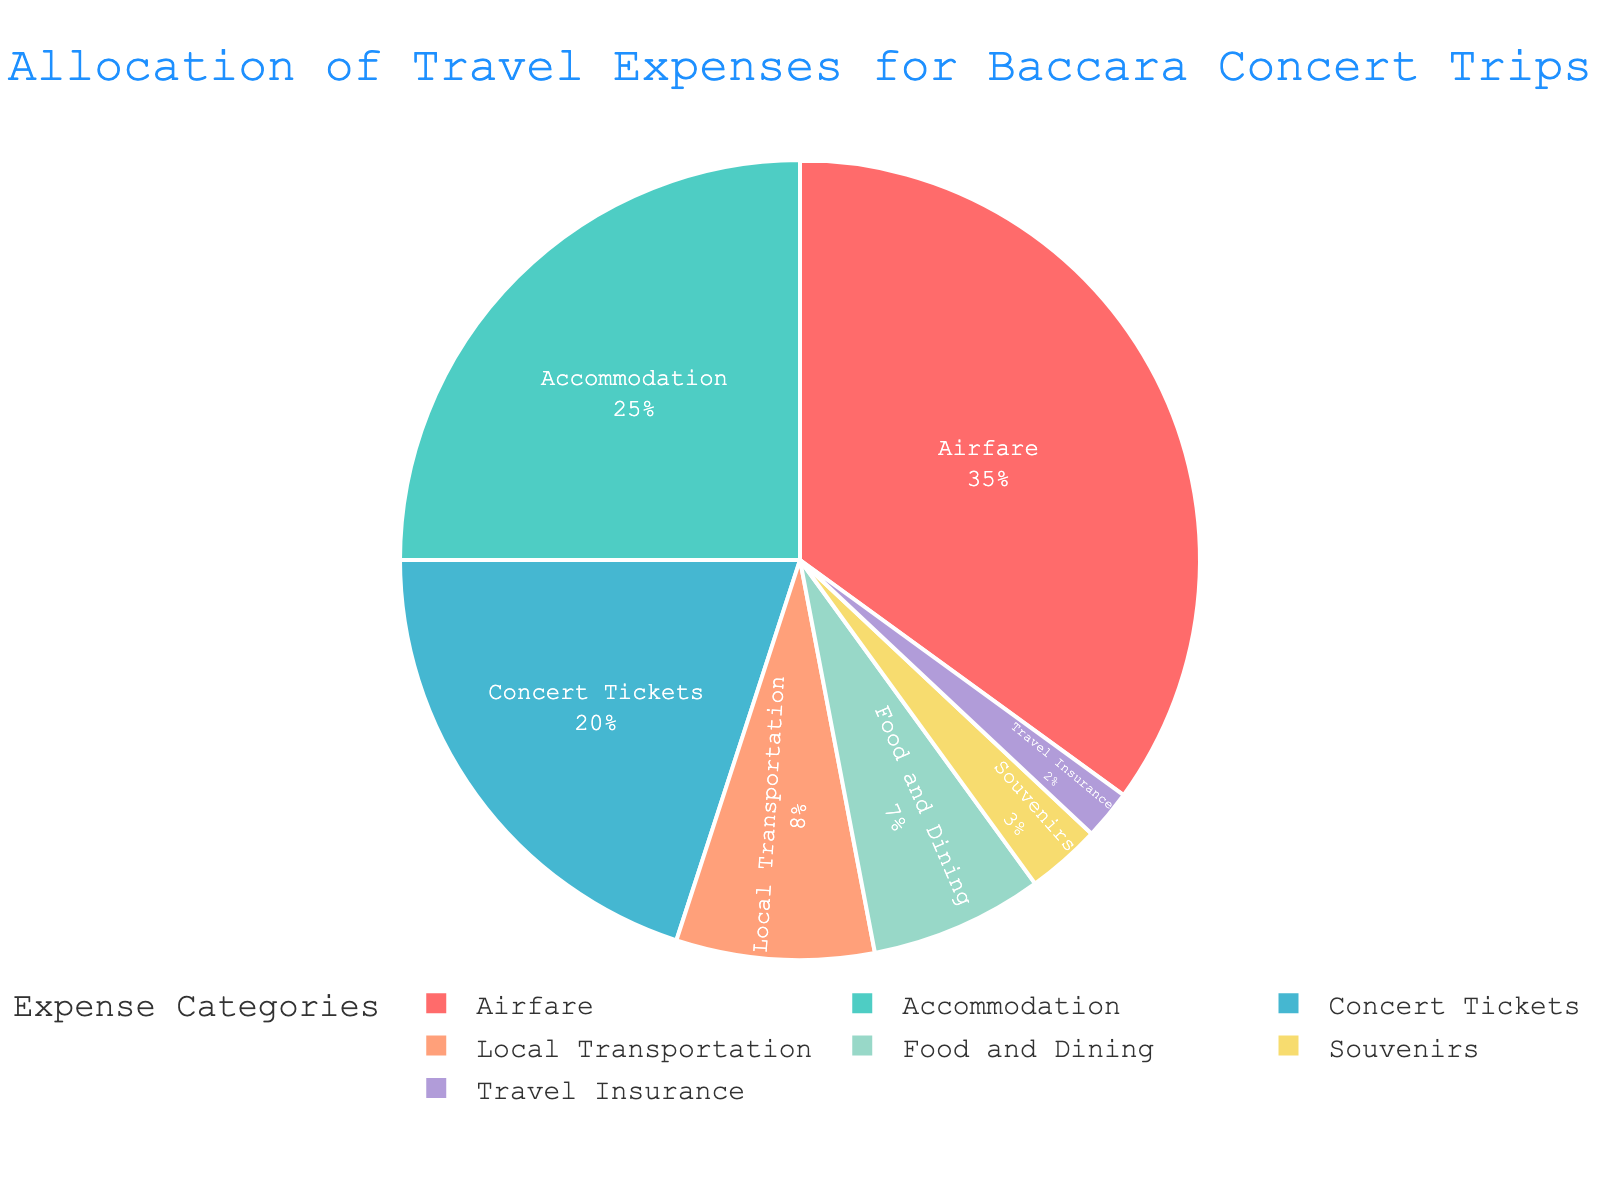What are the top three categories that consume the largest percentage of travel expenses? The top three categories can be identified by looking at the size of the pie slices. The largest slices correspond to Airfare, Accommodation, and Concert Tickets.
Answer: Airfare, Accommodation, Concert Tickets What percentage of the total travel expenses is spent on Local Transportation and Food and Dining combined? To find the combined percentage, add the values for Local Transportation (8%) and Food and Dining (7%). 8% + 7% = 15%.
Answer: 15% How does the percentage allocated to Airfare compare to the percentage allocated to Concert Tickets? To compare the two percentages, look at the values for Airfare (35%) and Concert Tickets (20%). Airfare has a higher percentage than Concert Tickets.
Answer: Airfare > Concert Tickets Which category has the smallest allocation, and what is its percentage? The smallest pie slice corresponds to Travel Insurance. The percentage value is 2%, which is the smallest among all categories.
Answer: Travel Insurance, 2% Is the percentage of the budget spent on Souvenirs greater than the budget spent on Travel Insurance? Compare the percentages for Souvenirs (3%) and Travel Insurance (2%). Souvenirs has a slightly higher percentage than Travel Insurance.
Answer: Yes What is the difference in percentage between the highest and lowest expense categories? Identify the highest percentage (Airfare, 35%) and the lowest percentage (Travel Insurance, 2%), then calculate the difference. 35% - 2% = 33%.
Answer: 33% What is the combined percentage of the expenses that are less than 10% each? Identify the categories with percentages less than 10%: Local Transportation (8%), Food and Dining (7%), Souvenirs (3%), and Travel Insurance (2%). Then add these values: 8% + 7% + 3% + 2% = 20%.
Answer: 20% How does the budget for Accommodation compare to the budget for Local Transportation and Souvenirs combined? Compare Accommodation (25%) to the combined sum of Local Transportation (8%) and Souvenirs (3%). 8% + 3% = 11%, which is less than the 25% for Accommodation.
Answer: Accommodation > Local Transportation + Souvenirs Which expense category is represented by the color green? The category represented by the color green is Accommodation.
Answer: Accommodation 